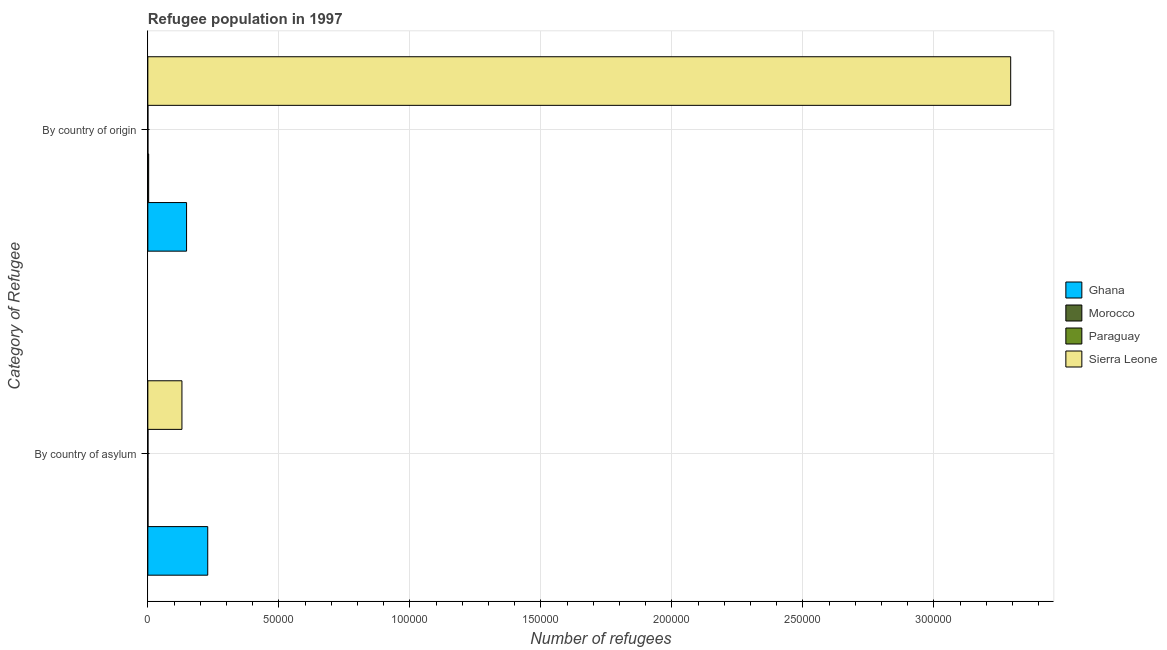How many different coloured bars are there?
Give a very brief answer. 4. Are the number of bars per tick equal to the number of legend labels?
Your answer should be compact. Yes. Are the number of bars on each tick of the Y-axis equal?
Give a very brief answer. Yes. What is the label of the 2nd group of bars from the top?
Keep it short and to the point. By country of asylum. What is the number of refugees by country of origin in Sierra Leone?
Provide a short and direct response. 3.29e+05. Across all countries, what is the maximum number of refugees by country of asylum?
Ensure brevity in your answer.  2.29e+04. Across all countries, what is the minimum number of refugees by country of origin?
Your response must be concise. 20. In which country was the number of refugees by country of origin maximum?
Your answer should be very brief. Sierra Leone. In which country was the number of refugees by country of asylum minimum?
Make the answer very short. Paraguay. What is the total number of refugees by country of origin in the graph?
Offer a very short reply. 3.44e+05. What is the difference between the number of refugees by country of asylum in Ghana and that in Morocco?
Offer a very short reply. 2.28e+04. What is the difference between the number of refugees by country of asylum in Paraguay and the number of refugees by country of origin in Morocco?
Your response must be concise. -263. What is the average number of refugees by country of origin per country?
Offer a very short reply. 8.61e+04. What is the difference between the number of refugees by country of origin and number of refugees by country of asylum in Ghana?
Provide a short and direct response. -8083. What is the ratio of the number of refugees by country of origin in Sierra Leone to that in Ghana?
Offer a terse response. 22.29. Is the number of refugees by country of asylum in Ghana less than that in Morocco?
Give a very brief answer. No. What does the 1st bar from the top in By country of origin represents?
Make the answer very short. Sierra Leone. What does the 3rd bar from the bottom in By country of asylum represents?
Offer a terse response. Paraguay. Are all the bars in the graph horizontal?
Offer a terse response. Yes. What is the difference between two consecutive major ticks on the X-axis?
Your response must be concise. 5.00e+04. Are the values on the major ticks of X-axis written in scientific E-notation?
Your answer should be compact. No. Does the graph contain any zero values?
Give a very brief answer. No. How many legend labels are there?
Provide a succinct answer. 4. How are the legend labels stacked?
Your answer should be very brief. Vertical. What is the title of the graph?
Your response must be concise. Refugee population in 1997. Does "New Zealand" appear as one of the legend labels in the graph?
Ensure brevity in your answer.  No. What is the label or title of the X-axis?
Your answer should be very brief. Number of refugees. What is the label or title of the Y-axis?
Provide a short and direct response. Category of Refugee. What is the Number of refugees of Ghana in By country of asylum?
Give a very brief answer. 2.29e+04. What is the Number of refugees in Paraguay in By country of asylum?
Make the answer very short. 47. What is the Number of refugees of Sierra Leone in By country of asylum?
Ensure brevity in your answer.  1.30e+04. What is the Number of refugees of Ghana in By country of origin?
Your answer should be very brief. 1.48e+04. What is the Number of refugees of Morocco in By country of origin?
Offer a terse response. 310. What is the Number of refugees of Sierra Leone in By country of origin?
Provide a short and direct response. 3.29e+05. Across all Category of Refugee, what is the maximum Number of refugees in Ghana?
Offer a very short reply. 2.29e+04. Across all Category of Refugee, what is the maximum Number of refugees of Morocco?
Your answer should be very brief. 310. Across all Category of Refugee, what is the maximum Number of refugees of Paraguay?
Your response must be concise. 47. Across all Category of Refugee, what is the maximum Number of refugees of Sierra Leone?
Provide a short and direct response. 3.29e+05. Across all Category of Refugee, what is the minimum Number of refugees in Ghana?
Ensure brevity in your answer.  1.48e+04. Across all Category of Refugee, what is the minimum Number of refugees in Sierra Leone?
Offer a terse response. 1.30e+04. What is the total Number of refugees of Ghana in the graph?
Keep it short and to the point. 3.76e+04. What is the total Number of refugees in Morocco in the graph?
Make the answer very short. 367. What is the total Number of refugees in Paraguay in the graph?
Offer a very short reply. 67. What is the total Number of refugees of Sierra Leone in the graph?
Offer a terse response. 3.42e+05. What is the difference between the Number of refugees of Ghana in By country of asylum and that in By country of origin?
Give a very brief answer. 8083. What is the difference between the Number of refugees of Morocco in By country of asylum and that in By country of origin?
Offer a very short reply. -253. What is the difference between the Number of refugees in Paraguay in By country of asylum and that in By country of origin?
Provide a short and direct response. 27. What is the difference between the Number of refugees in Sierra Leone in By country of asylum and that in By country of origin?
Your answer should be very brief. -3.16e+05. What is the difference between the Number of refugees of Ghana in By country of asylum and the Number of refugees of Morocco in By country of origin?
Give a very brief answer. 2.25e+04. What is the difference between the Number of refugees in Ghana in By country of asylum and the Number of refugees in Paraguay in By country of origin?
Offer a very short reply. 2.28e+04. What is the difference between the Number of refugees in Ghana in By country of asylum and the Number of refugees in Sierra Leone in By country of origin?
Make the answer very short. -3.06e+05. What is the difference between the Number of refugees of Morocco in By country of asylum and the Number of refugees of Sierra Leone in By country of origin?
Offer a very short reply. -3.29e+05. What is the difference between the Number of refugees of Paraguay in By country of asylum and the Number of refugees of Sierra Leone in By country of origin?
Ensure brevity in your answer.  -3.29e+05. What is the average Number of refugees in Ghana per Category of Refugee?
Keep it short and to the point. 1.88e+04. What is the average Number of refugees in Morocco per Category of Refugee?
Provide a short and direct response. 183.5. What is the average Number of refugees in Paraguay per Category of Refugee?
Ensure brevity in your answer.  33.5. What is the average Number of refugees in Sierra Leone per Category of Refugee?
Offer a very short reply. 1.71e+05. What is the difference between the Number of refugees in Ghana and Number of refugees in Morocco in By country of asylum?
Give a very brief answer. 2.28e+04. What is the difference between the Number of refugees of Ghana and Number of refugees of Paraguay in By country of asylum?
Ensure brevity in your answer.  2.28e+04. What is the difference between the Number of refugees in Ghana and Number of refugees in Sierra Leone in By country of asylum?
Your response must be concise. 9847. What is the difference between the Number of refugees in Morocco and Number of refugees in Paraguay in By country of asylum?
Ensure brevity in your answer.  10. What is the difference between the Number of refugees in Morocco and Number of refugees in Sierra Leone in By country of asylum?
Provide a succinct answer. -1.30e+04. What is the difference between the Number of refugees of Paraguay and Number of refugees of Sierra Leone in By country of asylum?
Provide a short and direct response. -1.30e+04. What is the difference between the Number of refugees of Ghana and Number of refugees of Morocco in By country of origin?
Provide a short and direct response. 1.45e+04. What is the difference between the Number of refugees in Ghana and Number of refugees in Paraguay in By country of origin?
Your answer should be compact. 1.48e+04. What is the difference between the Number of refugees in Ghana and Number of refugees in Sierra Leone in By country of origin?
Offer a very short reply. -3.15e+05. What is the difference between the Number of refugees of Morocco and Number of refugees of Paraguay in By country of origin?
Your answer should be compact. 290. What is the difference between the Number of refugees of Morocco and Number of refugees of Sierra Leone in By country of origin?
Give a very brief answer. -3.29e+05. What is the difference between the Number of refugees in Paraguay and Number of refugees in Sierra Leone in By country of origin?
Offer a very short reply. -3.29e+05. What is the ratio of the Number of refugees in Ghana in By country of asylum to that in By country of origin?
Offer a terse response. 1.55. What is the ratio of the Number of refugees of Morocco in By country of asylum to that in By country of origin?
Offer a terse response. 0.18. What is the ratio of the Number of refugees of Paraguay in By country of asylum to that in By country of origin?
Offer a very short reply. 2.35. What is the ratio of the Number of refugees in Sierra Leone in By country of asylum to that in By country of origin?
Keep it short and to the point. 0.04. What is the difference between the highest and the second highest Number of refugees of Ghana?
Keep it short and to the point. 8083. What is the difference between the highest and the second highest Number of refugees of Morocco?
Ensure brevity in your answer.  253. What is the difference between the highest and the second highest Number of refugees of Paraguay?
Give a very brief answer. 27. What is the difference between the highest and the second highest Number of refugees of Sierra Leone?
Give a very brief answer. 3.16e+05. What is the difference between the highest and the lowest Number of refugees in Ghana?
Offer a terse response. 8083. What is the difference between the highest and the lowest Number of refugees in Morocco?
Provide a short and direct response. 253. What is the difference between the highest and the lowest Number of refugees in Paraguay?
Offer a very short reply. 27. What is the difference between the highest and the lowest Number of refugees in Sierra Leone?
Your response must be concise. 3.16e+05. 